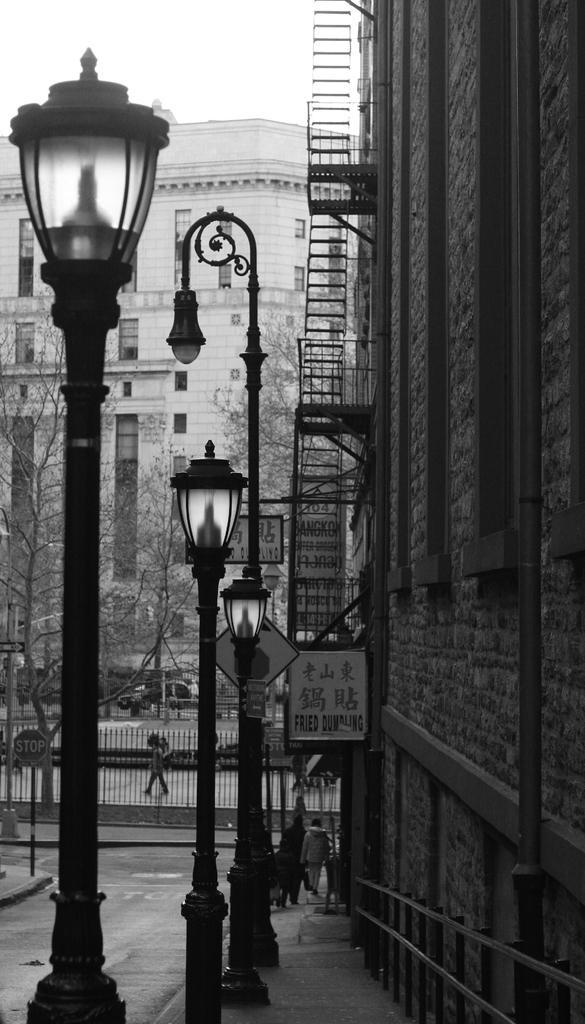Please provide a concise description of this image. In the image we can see black and white picture of the buildings and windows of the buildings. We can even see light poles, fence, road, ladder and the sky. We can even see there are people walking and wearing clothes. There are even vehicles on the road. 